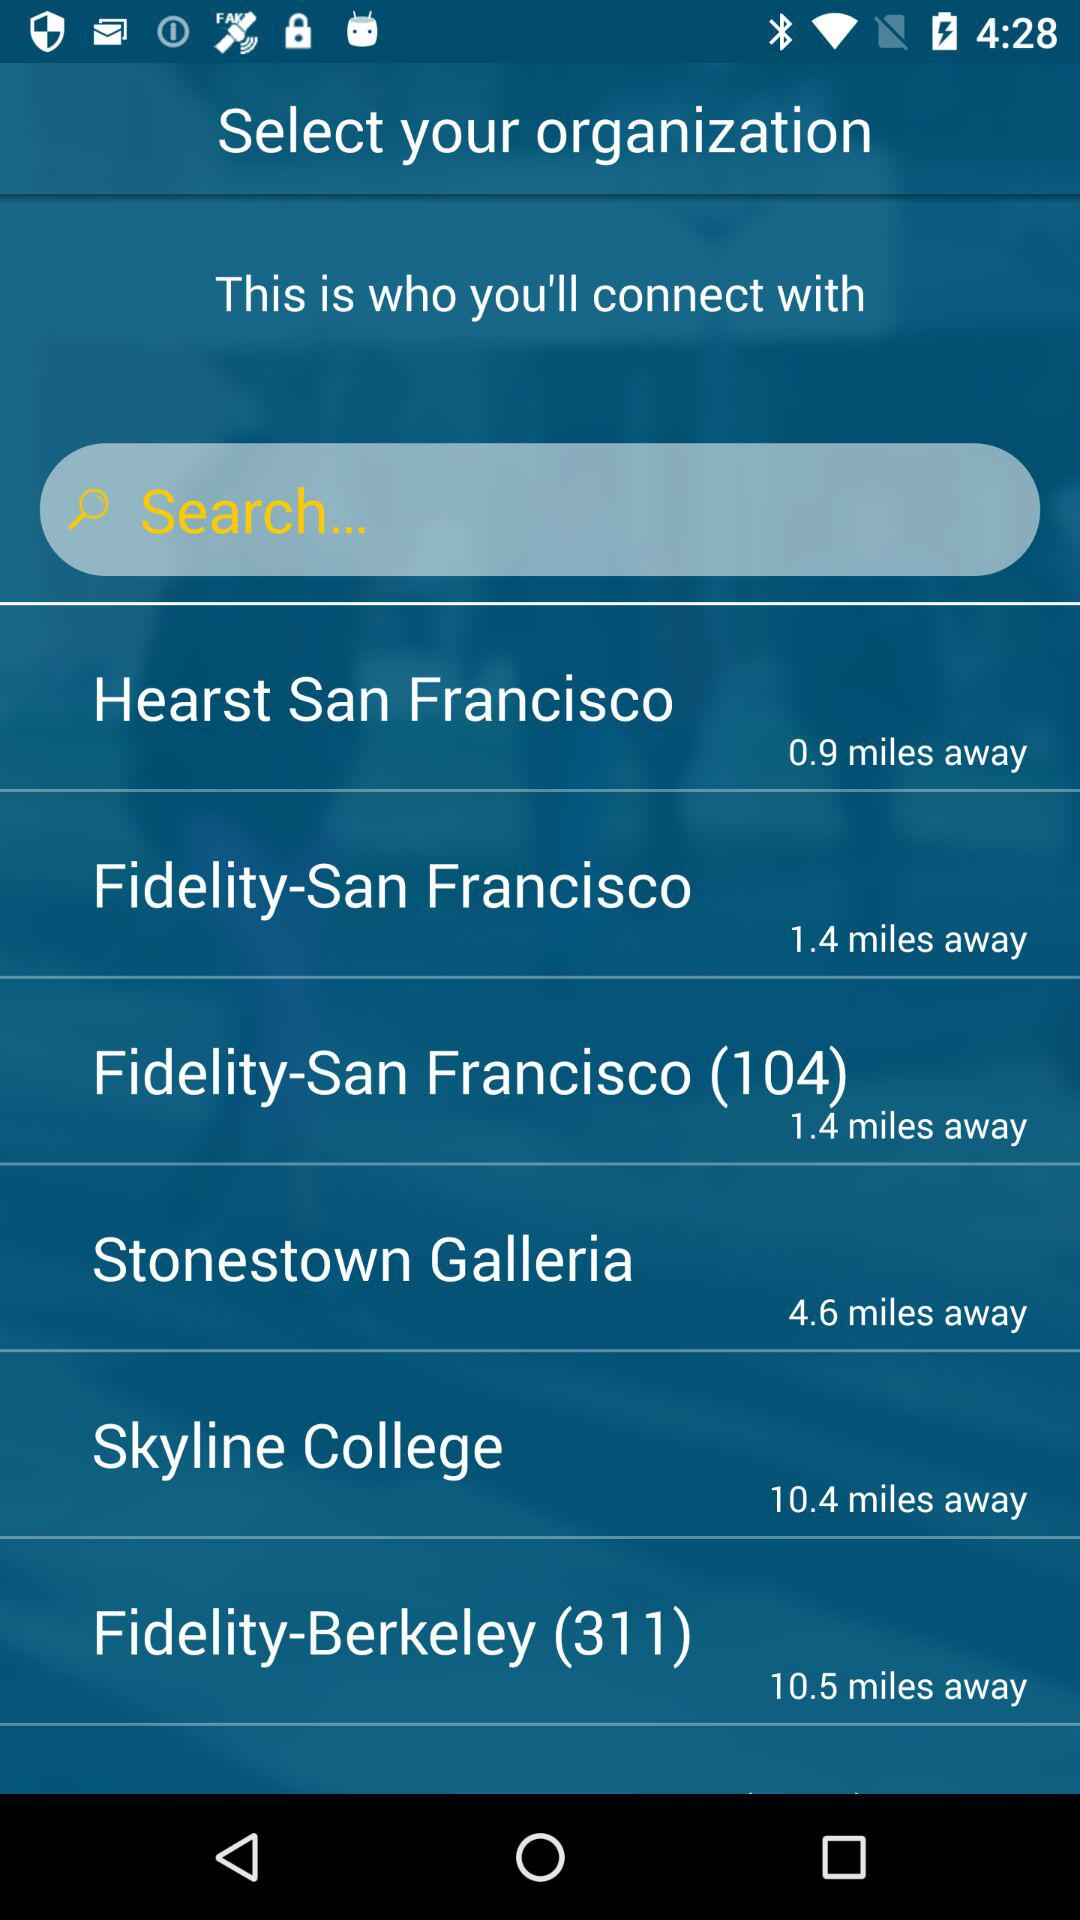What organisation is at a distance of 10.5 miles? The organisation is "Fidelity-Berkeley (311)". 